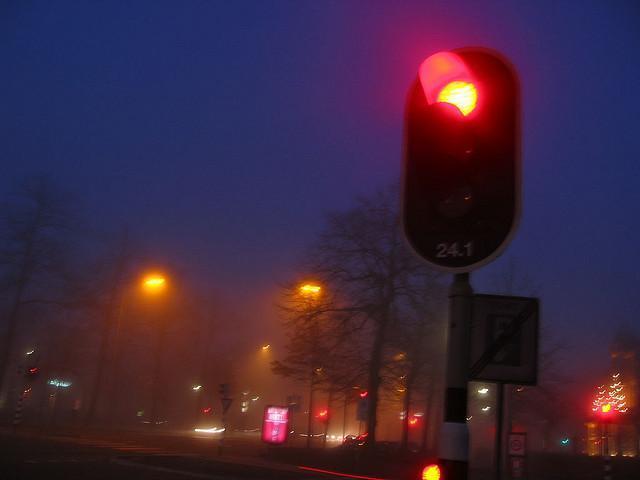How many people are sitting?
Give a very brief answer. 0. 